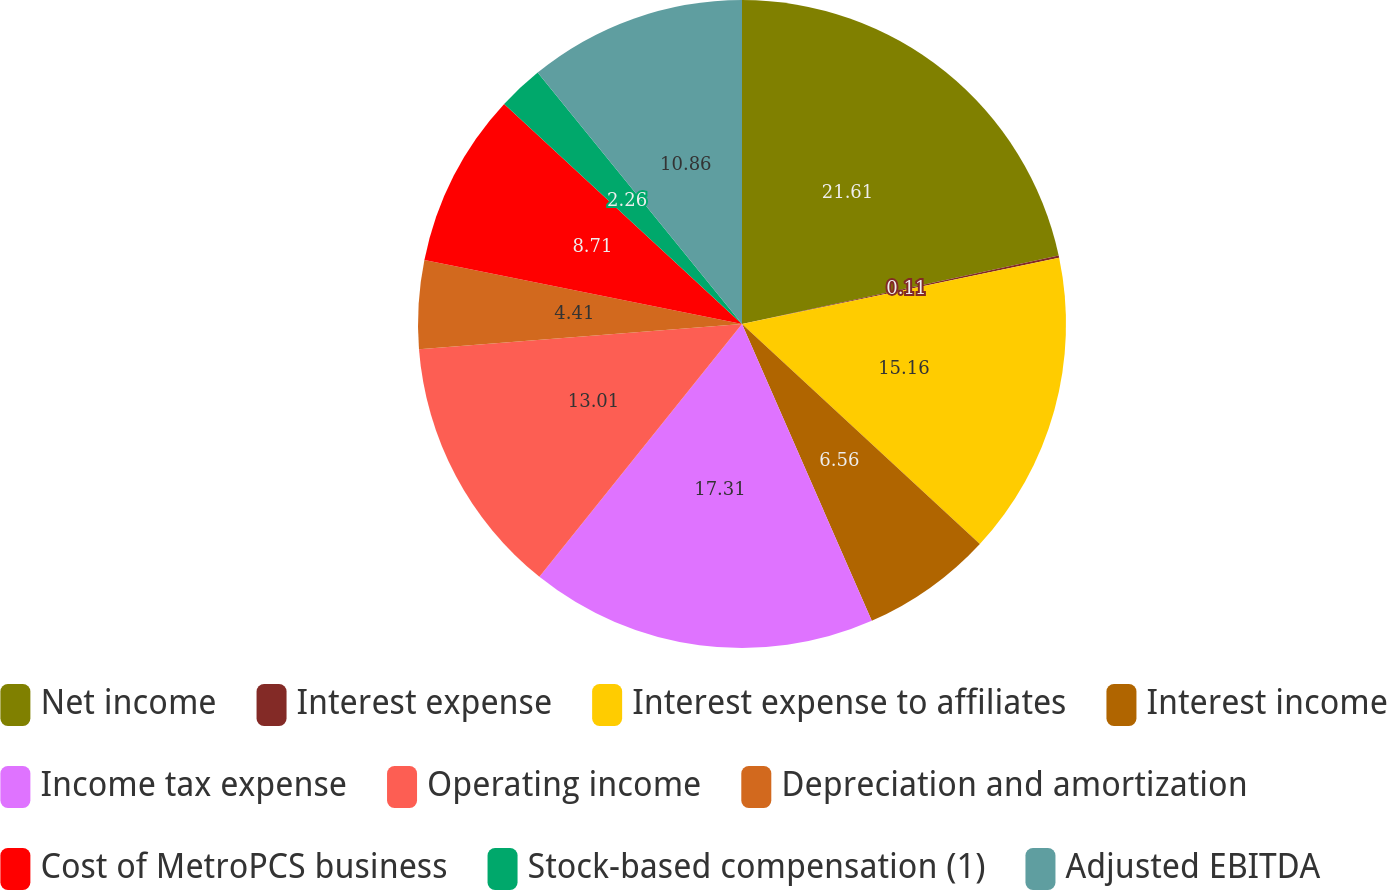<chart> <loc_0><loc_0><loc_500><loc_500><pie_chart><fcel>Net income<fcel>Interest expense<fcel>Interest expense to affiliates<fcel>Interest income<fcel>Income tax expense<fcel>Operating income<fcel>Depreciation and amortization<fcel>Cost of MetroPCS business<fcel>Stock-based compensation (1)<fcel>Adjusted EBITDA<nl><fcel>21.61%<fcel>0.11%<fcel>15.16%<fcel>6.56%<fcel>17.31%<fcel>13.01%<fcel>4.41%<fcel>8.71%<fcel>2.26%<fcel>10.86%<nl></chart> 